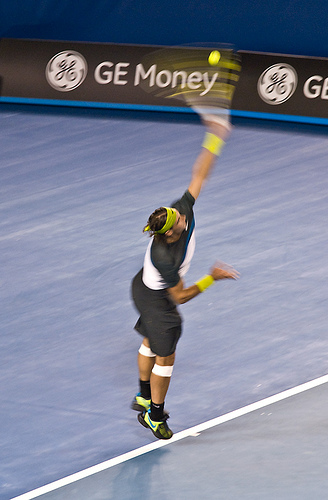Please identify all text content in this image. GE Money GE 